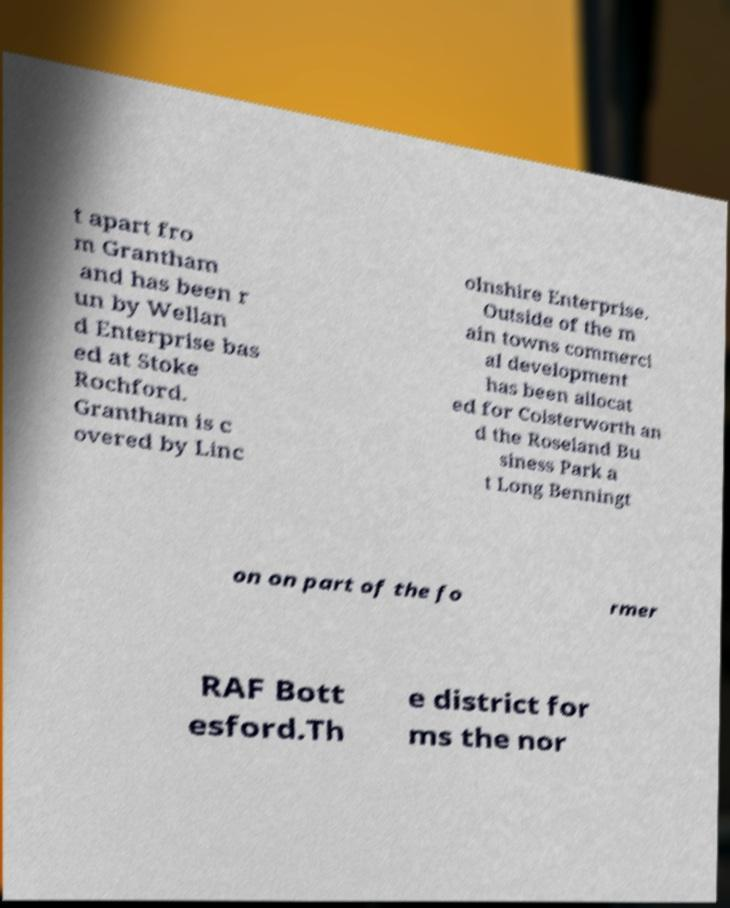Could you extract and type out the text from this image? t apart fro m Grantham and has been r un by Wellan d Enterprise bas ed at Stoke Rochford. Grantham is c overed by Linc olnshire Enterprise. Outside of the m ain towns commerci al development has been allocat ed for Colsterworth an d the Roseland Bu siness Park a t Long Benningt on on part of the fo rmer RAF Bott esford.Th e district for ms the nor 